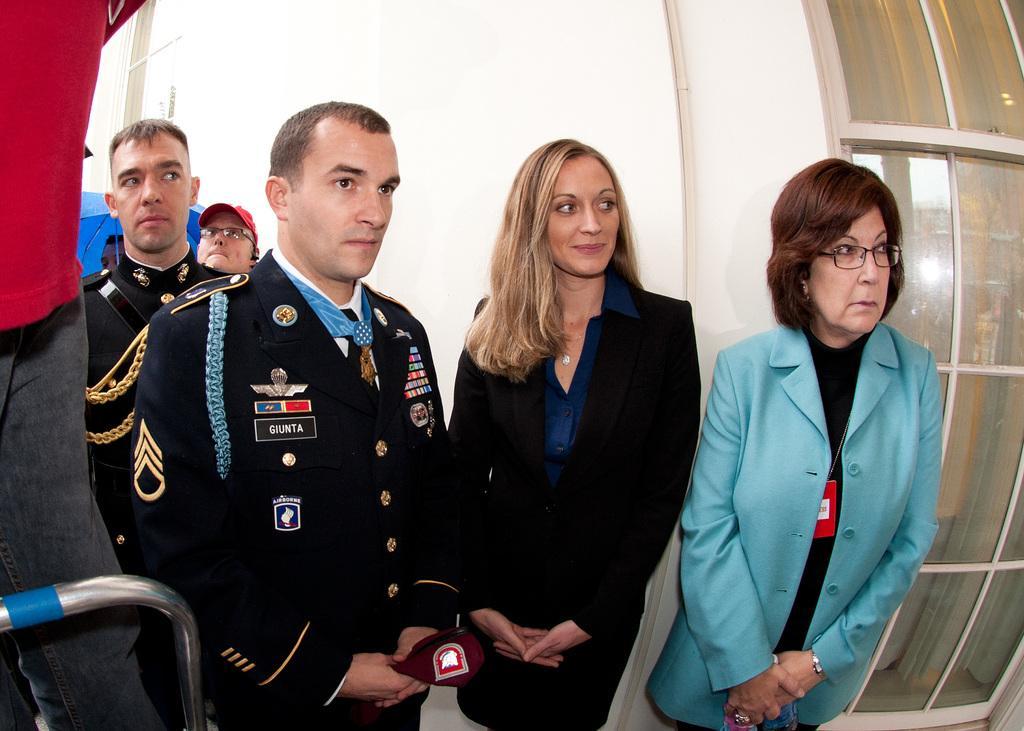In one or two sentences, can you explain what this image depicts? In this picture we can observe some people standing. There were men and women in this picture. On the left side there is a person standing wearing a red color T shirt. In the background there is a wall. 